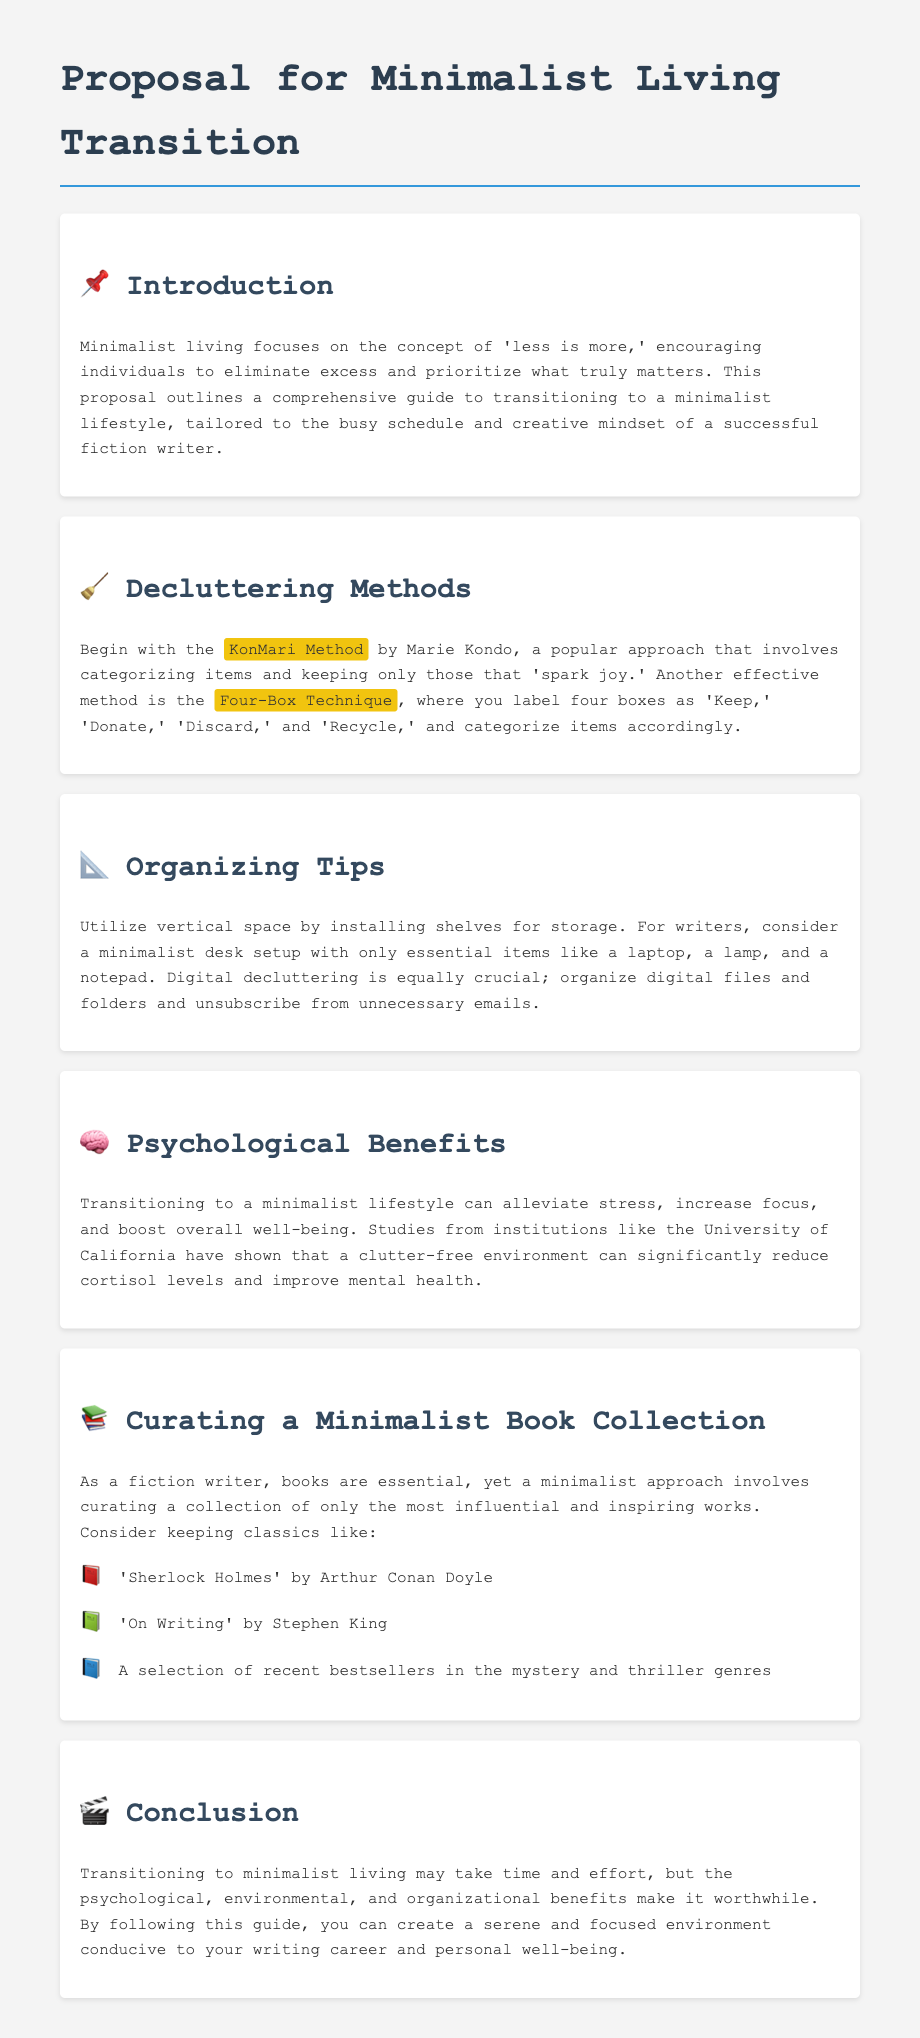What is the main focus of minimalist living? The main focus of minimalist living is the concept of 'less is more,' encouraging individuals to eliminate excess and prioritize what truly matters.
Answer: less is more Which decluttering method involves categorizing items that 'spark joy'? This method, developed by Marie Kondo, categorizes items that bring joy and is known as the KonMari Method.
Answer: KonMari Method What are the four labels used in the Four-Box Technique? The labels in the Four-Box Technique are 'Keep,' 'Donate,' 'Discard,' and 'Recycle.'
Answer: Keep, Donate, Discard, Recycle What is one psychological benefit of transitioning to a minimalist lifestyle? Transitioning to a minimalist lifestyle can alleviate stress, increase focus, and boost overall well-being.
Answer: alleviate stress Which book by Stephen King is suggested for a minimalist book collection? The book recommended by Stephen King for a minimalist book collection is "On Writing."
Answer: On Writing What type of writing environment does the proposal aim to help create? The proposal aims to create a serene and focused environment conducive to writing.
Answer: serene and focused environment 